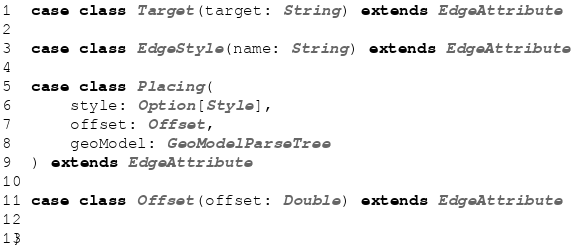Convert code to text. <code><loc_0><loc_0><loc_500><loc_500><_Scala_>
  case class Target(target: String) extends EdgeAttribute

  case class EdgeStyle(name: String) extends EdgeAttribute

  case class Placing(
      style: Option[Style],
      offset: Offset,
      geoModel: GeoModelParseTree
  ) extends EdgeAttribute

  case class Offset(offset: Double) extends EdgeAttribute

}
</code> 